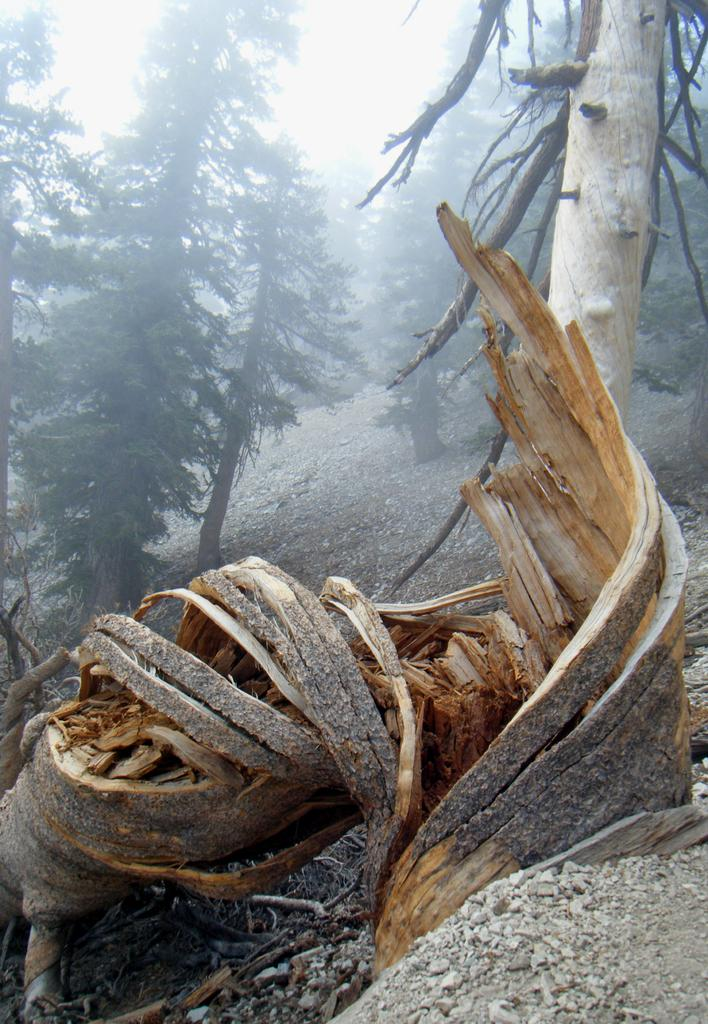What can be seen in the foreground of the image? There are trees, a broken trunk, small stones, and the ground visible in the foreground of the image. What is the condition of the trees in the foreground? The trees in the foreground appear to be standing. What is the background of the image? The sky is visible in the image. Is there a cave visible in the image? There is no cave present in the image. Are the trees in the foreground fighting with each other? The trees in the foreground are not fighting with each other; they are standing. 